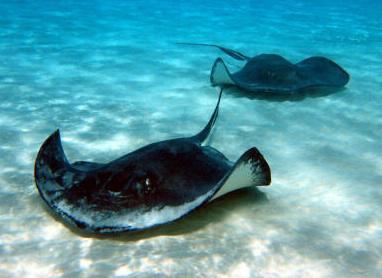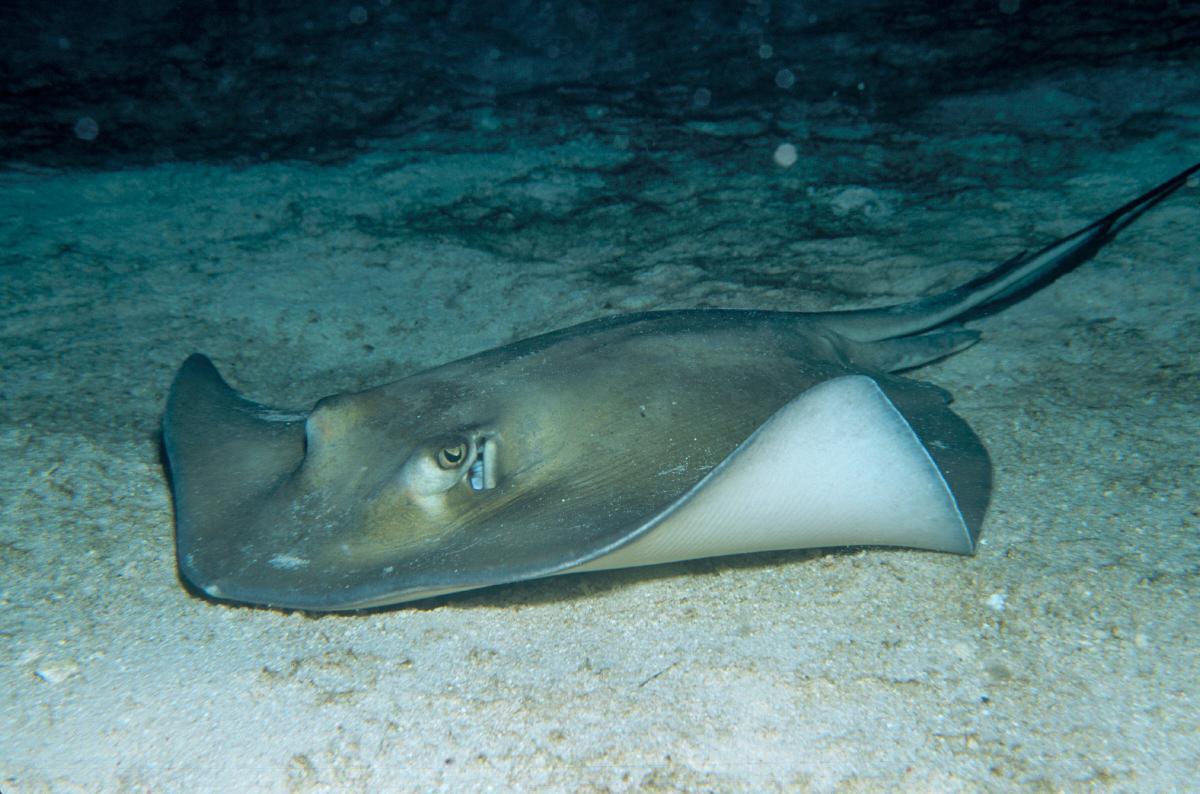The first image is the image on the left, the second image is the image on the right. Evaluate the accuracy of this statement regarding the images: "An image shows exactly two dark stingrays, including at least one that is nearly black.". Is it true? Answer yes or no. Yes. 